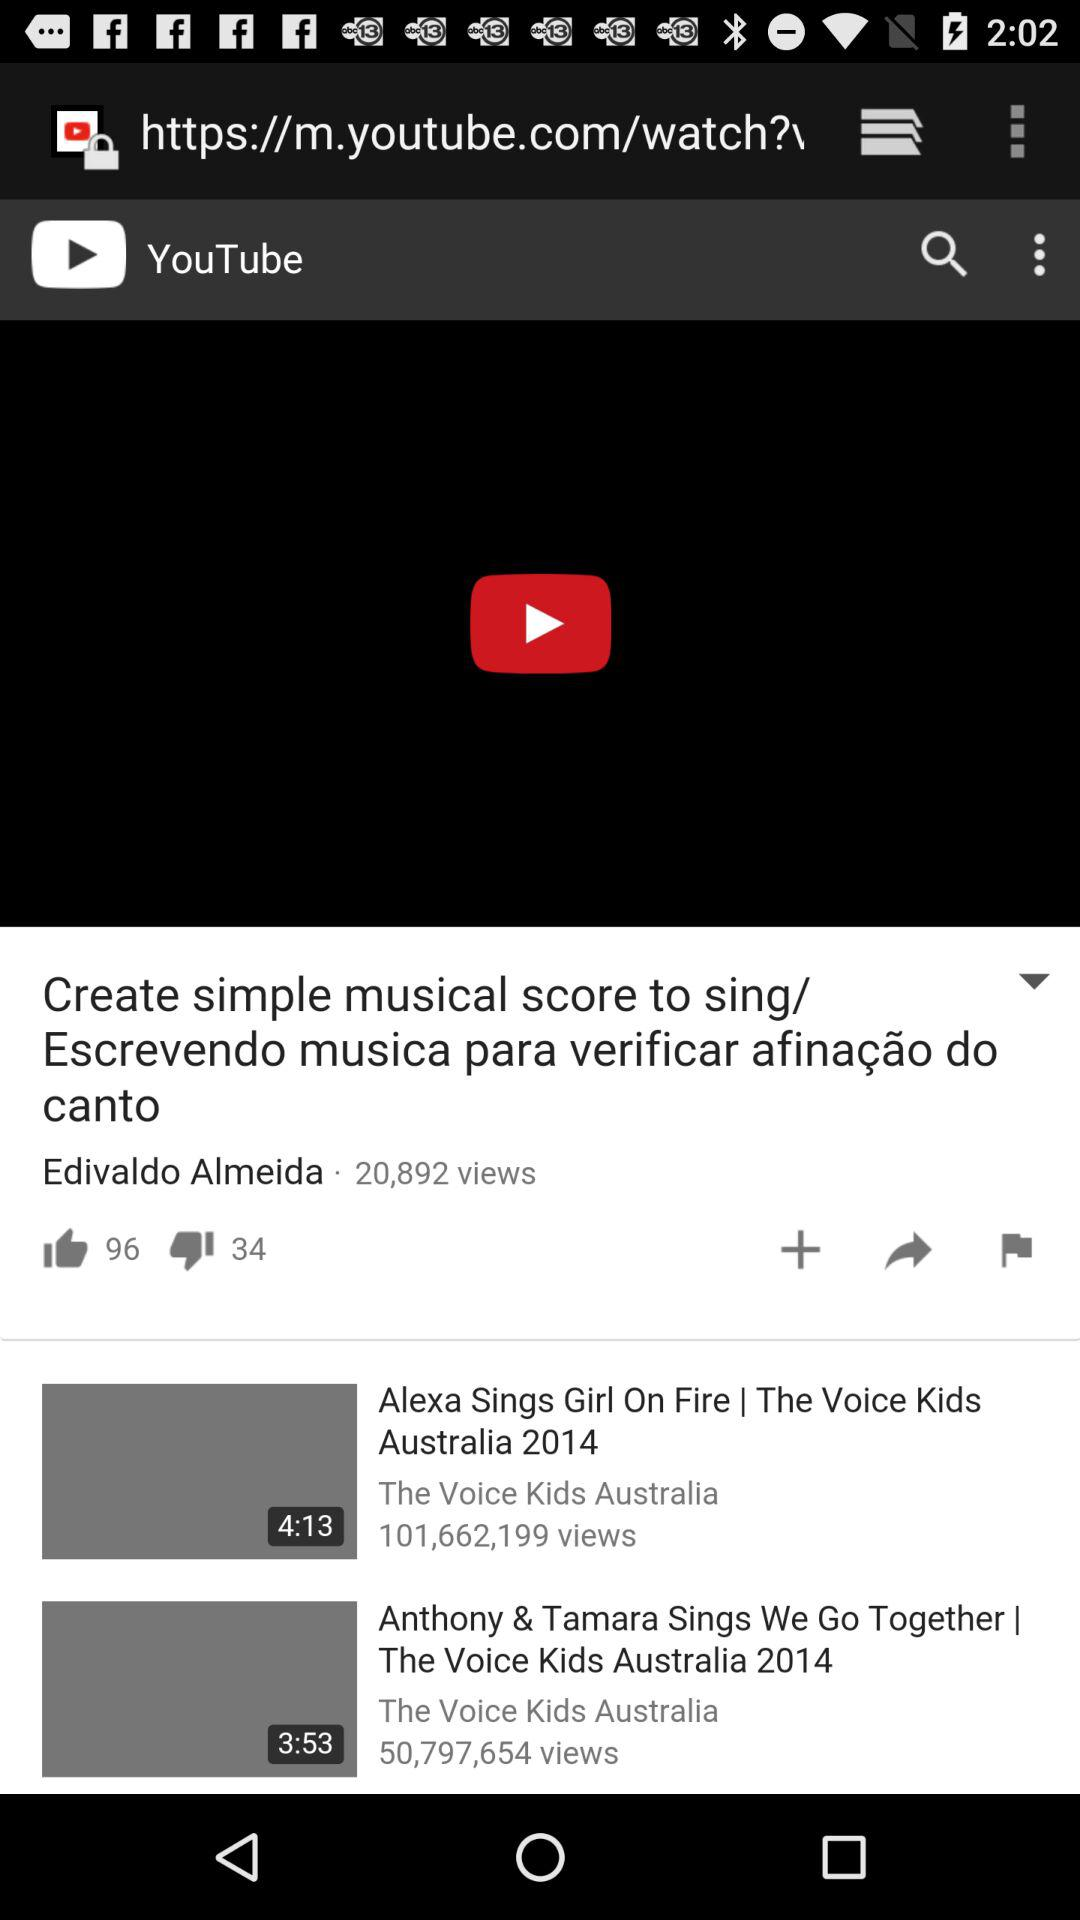How many more thumbs down than thumbs up are there on the video?
Answer the question using a single word or phrase. 62 